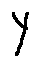<formula> <loc_0><loc_0><loc_500><loc_500>y</formula> 